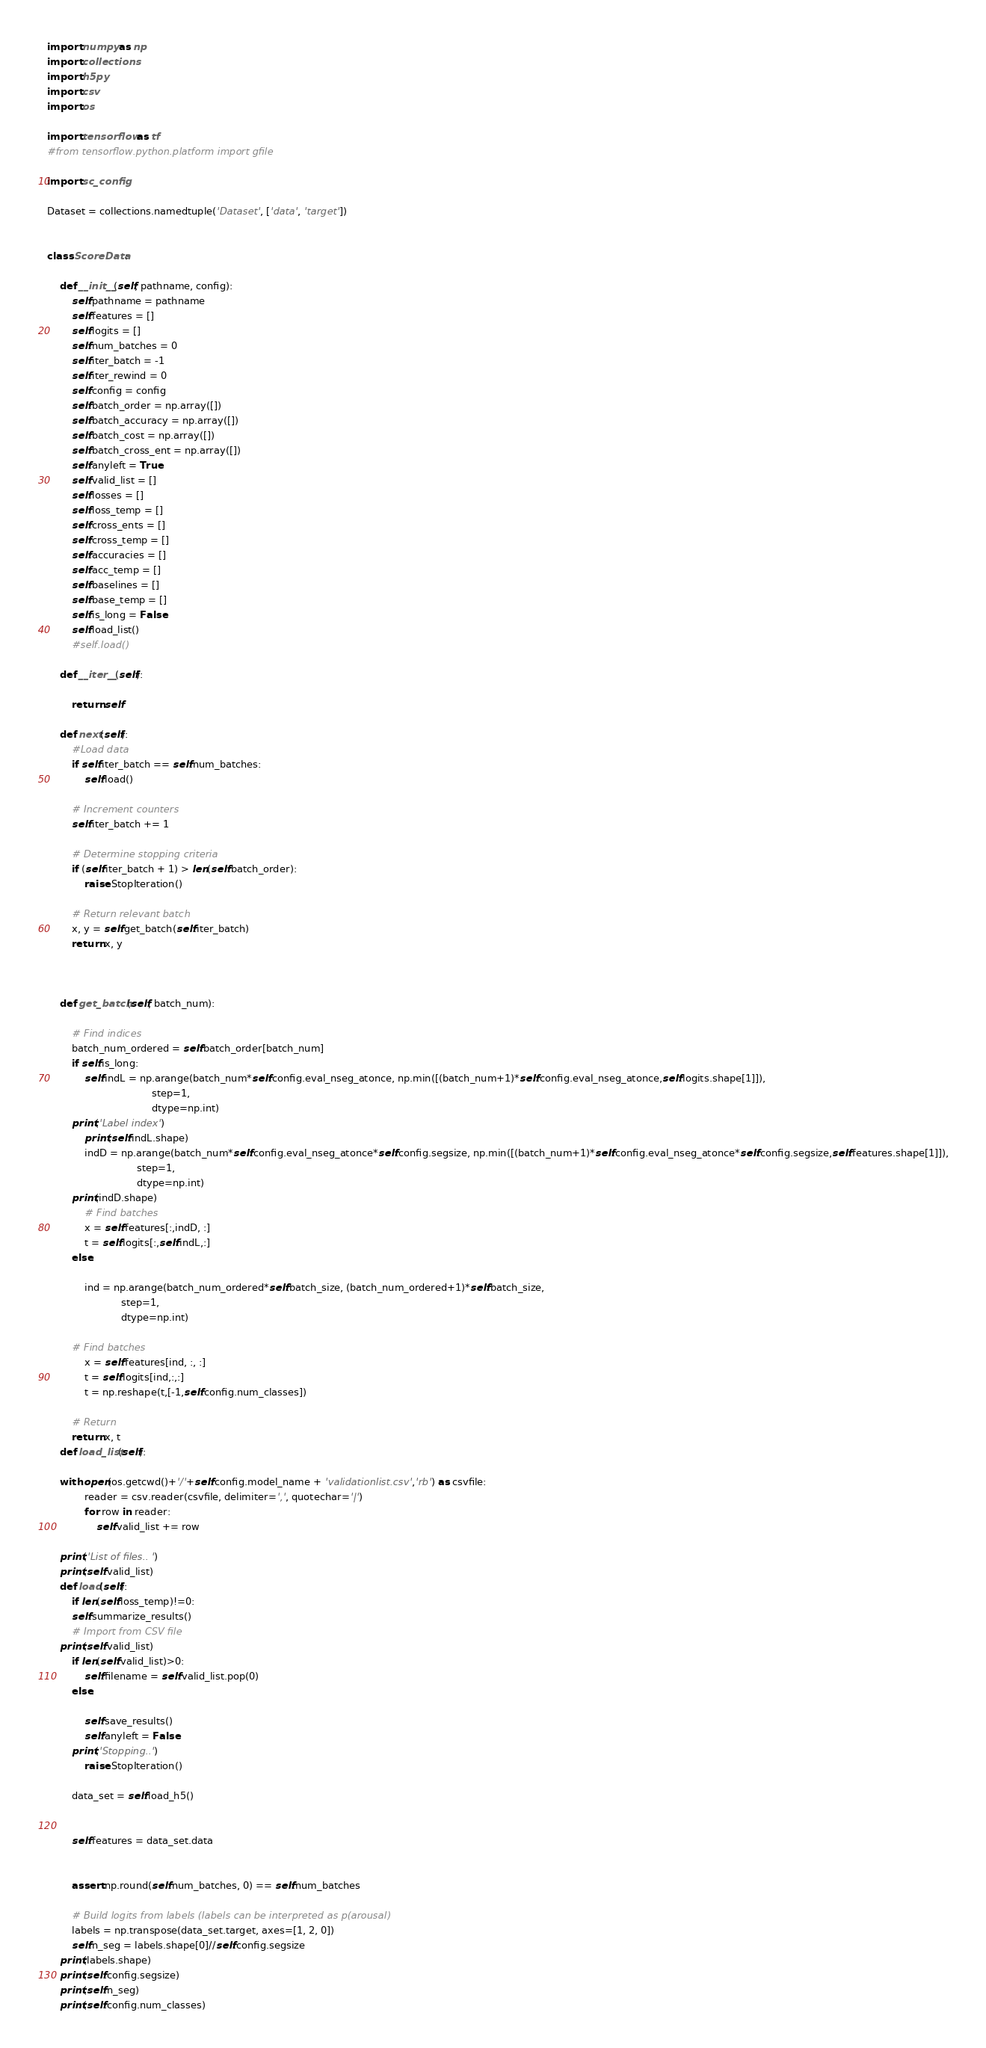<code> <loc_0><loc_0><loc_500><loc_500><_Python_>import numpy as np
import collections
import h5py
import csv
import os

import tensorflow as tf
#from tensorflow.python.platform import gfile

import sc_config

Dataset = collections.namedtuple('Dataset', ['data', 'target'])


class ScoreData:

    def __init__(self, pathname, config):
        self.pathname = pathname
        self.features = []
        self.logits = []
        self.num_batches = 0
        self.iter_batch = -1
        self.iter_rewind = 0
        self.config = config
        self.batch_order = np.array([])
        self.batch_accuracy = np.array([])
        self.batch_cost = np.array([])
        self.batch_cross_ent = np.array([])
        self.anyleft = True
        self.valid_list = []
        self.losses = []
        self.loss_temp = []
        self.cross_ents = []
        self.cross_temp = []
        self.accuracies = []
        self.acc_temp = []
        self.baselines = []
        self.base_temp = []
        self.is_long = False
        self.load_list()
        #self.load()

    def __iter__(self):

        return self

    def next(self):
        #Load data
        if self.iter_batch == self.num_batches:    
            self.load()
            
        # Increment counters
        self.iter_batch += 1

        # Determine stopping criteria
        if (self.iter_batch + 1) > len(self.batch_order):
            raise StopIteration()

        # Return relevant batch
        x, y = self.get_batch(self.iter_batch)
        return x, y



    def get_batch(self, batch_num):

        # Find indices
        batch_num_ordered = self.batch_order[batch_num]
        if self.is_long:
            self.indL = np.arange(batch_num*self.config.eval_nseg_atonce, np.min([(batch_num+1)*self.config.eval_nseg_atonce,self.logits.shape[1]]),
                                  step=1,
                                  dtype=np.int)
	    print('Label index')
            print(self.indL.shape)
            indD = np.arange(batch_num*self.config.eval_nseg_atonce*self.config.segsize, np.min([(batch_num+1)*self.config.eval_nseg_atonce*self.config.segsize,self.features.shape[1]]),
                             step=1,
                             dtype=np.int)
	    print(indD.shape)
            # Find batches
            x = self.features[:,indD, :]
            t = self.logits[:,self.indL,:]
        else:
                
            ind = np.arange(batch_num_ordered*self.batch_size, (batch_num_ordered+1)*self.batch_size,
                        step=1,
                        dtype=np.int)

        # Find batches
            x = self.features[ind, :, :]
            t = self.logits[ind,:,:]
            t = np.reshape(t,[-1,self.config.num_classes])

        # Return
        return x, t
    def load_list(self):
        
	with open(os.getcwd()+'/'+self.config.model_name + 'validationlist.csv','rb') as csvfile:
            reader = csv.reader(csvfile, delimiter=',', quotechar='|')
            for row in reader:
                self.valid_list += row
        
	print('List of files.. ')
	print(self.valid_list)
    def load(self):
        if len(self.loss_temp)!=0:
	    self.summarize_results()
        # Import from CSV file
	print(self.valid_list)
        if len(self.valid_list)>0:
            self.filename = self.valid_list.pop(0)
        else:
           
            self.save_results()
            self.anyleft = False            
	    print('Stopping..')
            raise StopIteration()
	   
        data_set = self.load_h5()
                

        self.features = data_set.data
 
               
        assert np.round(self.num_batches, 0) == self.num_batches

        # Build logits from labels (labels can be interpreted as p(arousal)
        labels = np.transpose(data_set.target, axes=[1, 2, 0])    
        self.n_seg = labels.shape[0]//self.config.segsize
	print(labels.shape)
	print(self.config.segsize)
	print(self.n_seg)
	print(self.config.num_classes)</code> 